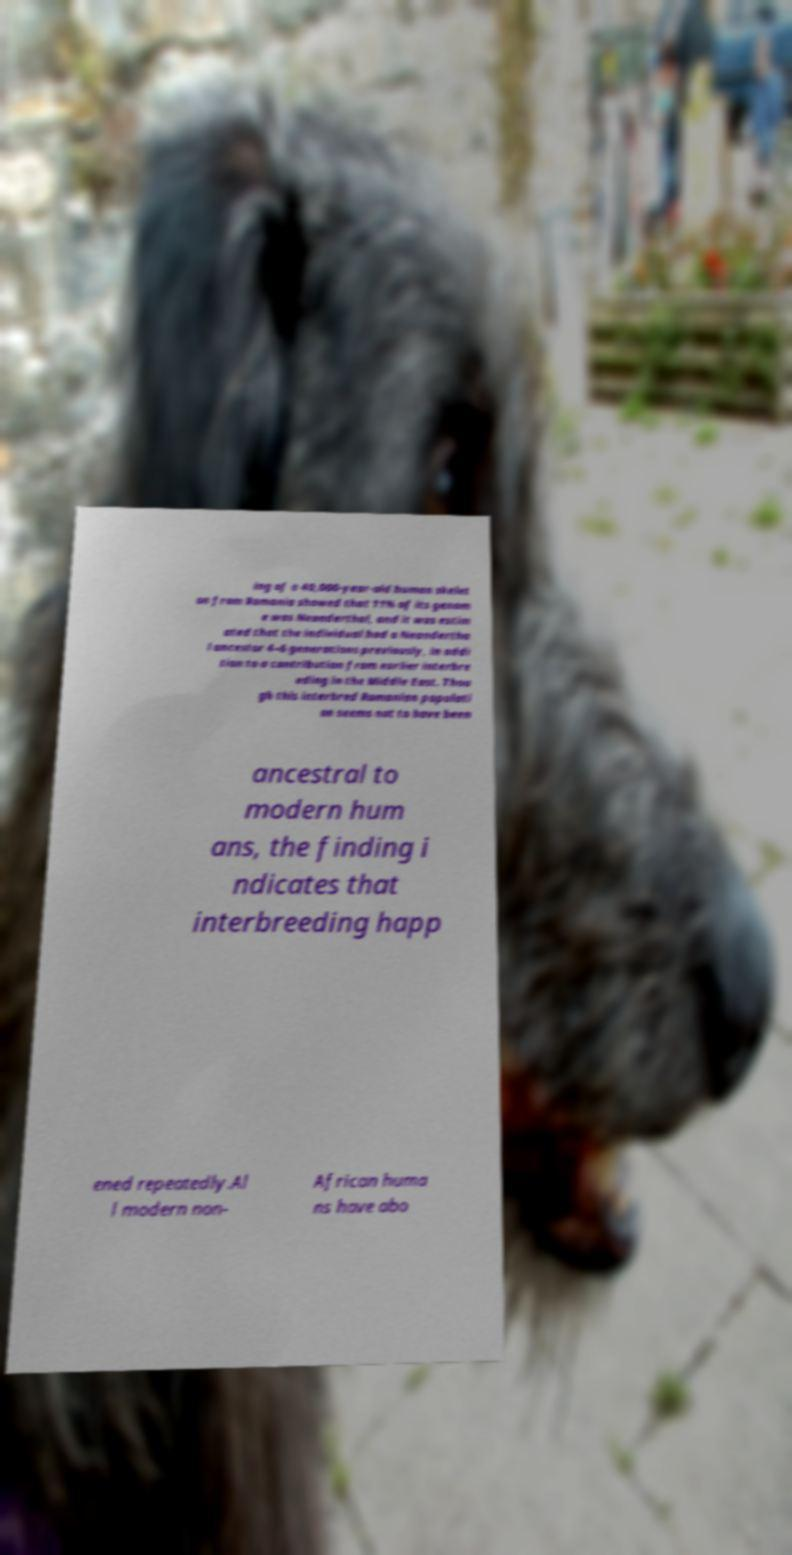Can you accurately transcribe the text from the provided image for me? ing of a 40,000-year-old human skelet on from Romania showed that 11% of its genom e was Neanderthal, and it was estim ated that the individual had a Neandertha l ancestor 4–6 generations previously, in addi tion to a contribution from earlier interbre eding in the Middle East. Thou gh this interbred Romanian populati on seems not to have been ancestral to modern hum ans, the finding i ndicates that interbreeding happ ened repeatedly.Al l modern non- African huma ns have abo 